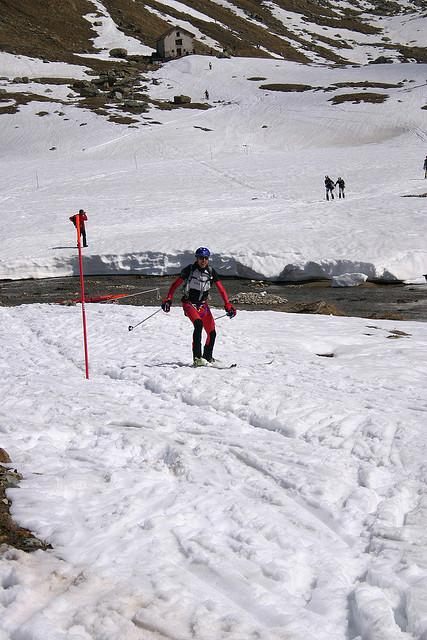What time of day is this? afternoon 